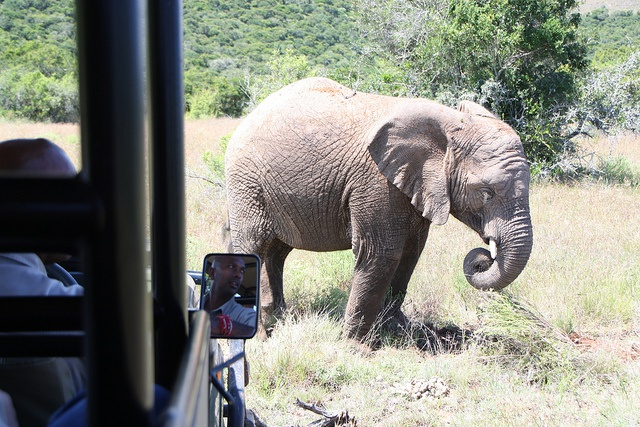Describe the objects in this image and their specific colors. I can see truck in blue, black, gray, darkgray, and navy tones, elephant in blue, lightgray, gray, black, and darkgray tones, people in blue, black, darkblue, and navy tones, and people in blue, black, and gray tones in this image. 